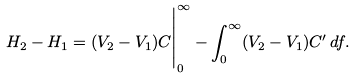<formula> <loc_0><loc_0><loc_500><loc_500>H _ { 2 } - H _ { 1 } = ( V _ { 2 } - V _ { 1 } ) C \Big | _ { 0 } ^ { \infty } - \int _ { 0 } ^ { \infty } ( V _ { 2 } - V _ { 1 } ) C ^ { \prime } \, { d } f .</formula> 